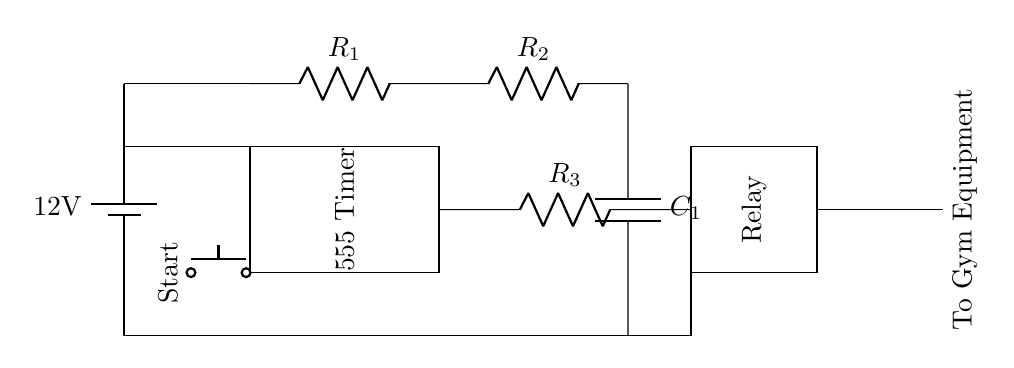What is the voltage of the power supply? The circuit features a battery labeled as providing 12 volts, which indicates the voltage across the power supply.
Answer: 12 volts What is the function of the 555 Timer in this circuit? The 555 Timer is designed to act as a timer or oscillator, controlling the duration for which the relay is activated based on the resistors and capacitor connected to it.
Answer: Timer What is connected to the output of the relay? The output from the relay is connected to the gym equipment, allowing it to power on or off based on the timer circuit's control.
Answer: Gym equipment What are the components used to set the timing in this circuit? The timing is set by the combination of Resistor R1, Resistor R2, and Capacitor C1, which determines the delay before the relay activates.
Answer: R1, R2, C1 How many resistors are in this circuit? There are three resistors in total: R1, R2, and R3, which are visible in the diagram.
Answer: Three What is used to initiate the timer circuit? The timer circuit is initiated by pressing the push button labeled "Start," which acts as a trigger for the 555 Timer.
Answer: Push button 